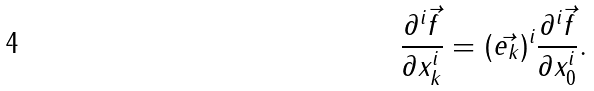<formula> <loc_0><loc_0><loc_500><loc_500>\frac { \partial ^ { i } \vec { f } } { \partial x _ { k } ^ { i } } = ( \vec { e _ { k } } ) ^ { i } \frac { \partial ^ { i } \vec { f } } { \partial x _ { 0 } ^ { i } } .</formula> 